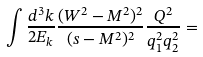<formula> <loc_0><loc_0><loc_500><loc_500>\int \frac { d ^ { 3 } k } { 2 E _ { k } } \frac { ( W ^ { 2 } - M ^ { 2 } ) ^ { 2 } } { ( s - M ^ { 2 } ) ^ { 2 } } \frac { Q ^ { 2 } } { q _ { 1 } ^ { 2 } q _ { 2 } ^ { 2 } } =</formula> 